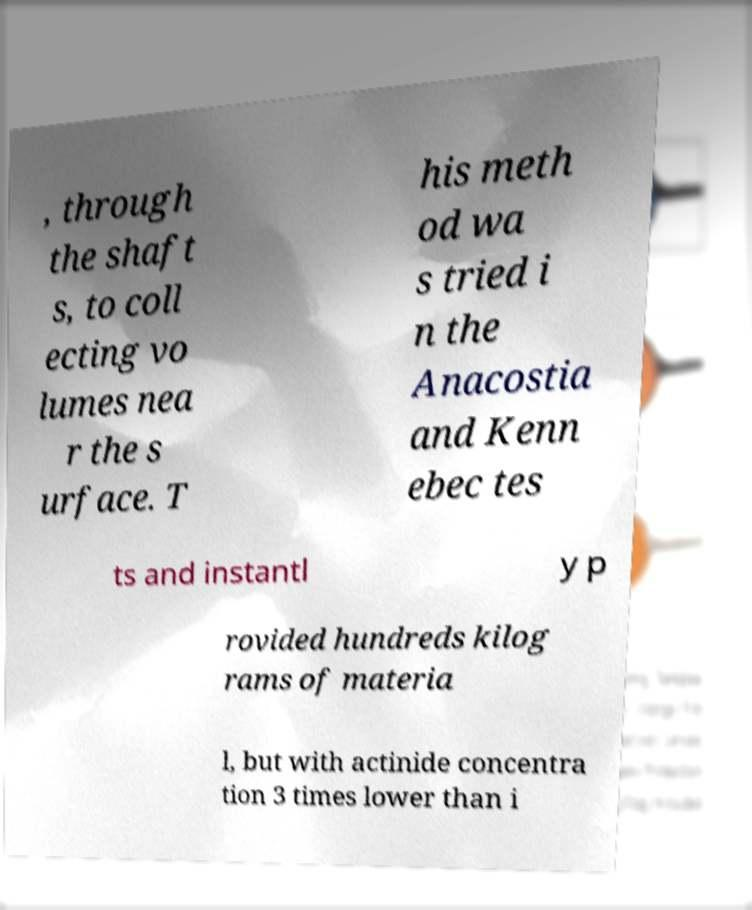There's text embedded in this image that I need extracted. Can you transcribe it verbatim? , through the shaft s, to coll ecting vo lumes nea r the s urface. T his meth od wa s tried i n the Anacostia and Kenn ebec tes ts and instantl y p rovided hundreds kilog rams of materia l, but with actinide concentra tion 3 times lower than i 